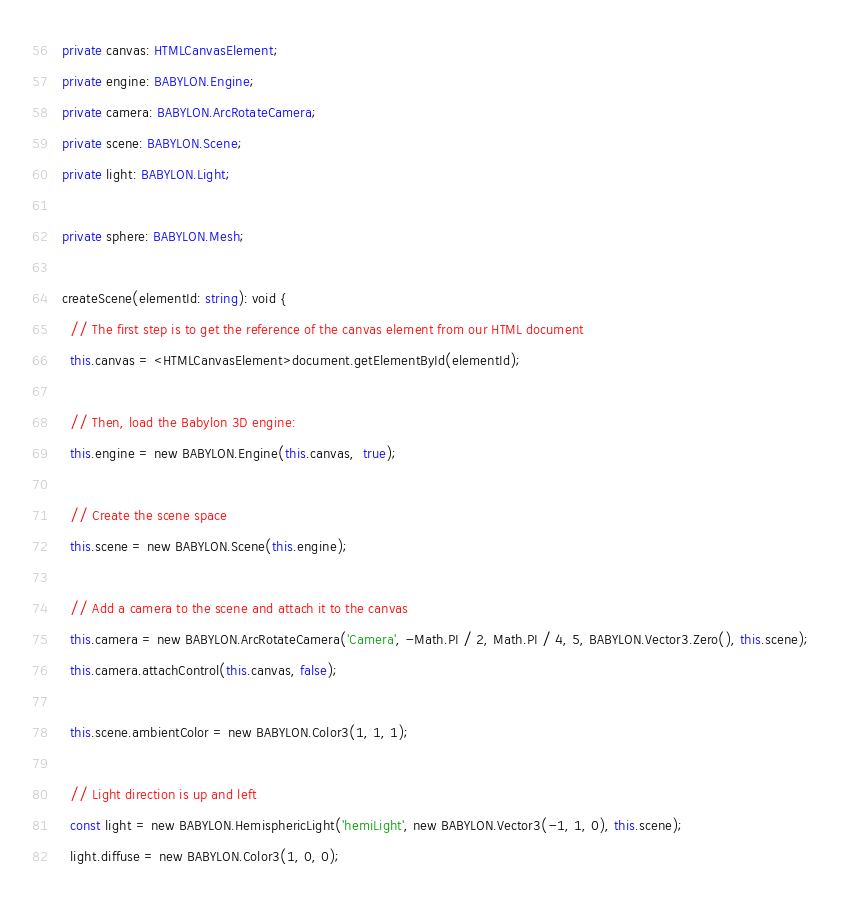Convert code to text. <code><loc_0><loc_0><loc_500><loc_500><_TypeScript_>  private canvas: HTMLCanvasElement;
  private engine: BABYLON.Engine;
  private camera: BABYLON.ArcRotateCamera;
  private scene: BABYLON.Scene;
  private light: BABYLON.Light;

  private sphere: BABYLON.Mesh;

  createScene(elementId: string): void {
    // The first step is to get the reference of the canvas element from our HTML document
    this.canvas = <HTMLCanvasElement>document.getElementById(elementId);

    // Then, load the Babylon 3D engine:
    this.engine = new BABYLON.Engine(this.canvas,  true);

    // Create the scene space
    this.scene = new BABYLON.Scene(this.engine);

    // Add a camera to the scene and attach it to the canvas
    this.camera = new BABYLON.ArcRotateCamera('Camera', -Math.PI / 2, Math.PI / 4, 5, BABYLON.Vector3.Zero(), this.scene);
    this.camera.attachControl(this.canvas, false);

    this.scene.ambientColor = new BABYLON.Color3(1, 1, 1);

    // Light direction is up and left
    const light = new BABYLON.HemisphericLight('hemiLight', new BABYLON.Vector3(-1, 1, 0), this.scene);
    light.diffuse = new BABYLON.Color3(1, 0, 0);</code> 